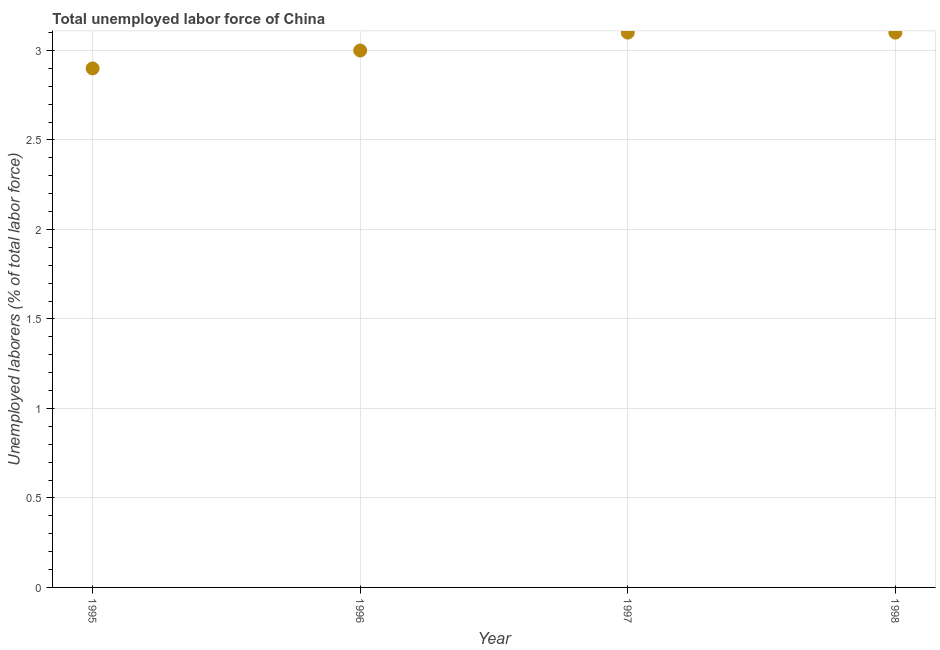What is the total unemployed labour force in 1997?
Make the answer very short. 3.1. Across all years, what is the maximum total unemployed labour force?
Give a very brief answer. 3.1. Across all years, what is the minimum total unemployed labour force?
Make the answer very short. 2.9. In which year was the total unemployed labour force maximum?
Offer a very short reply. 1997. What is the sum of the total unemployed labour force?
Your response must be concise. 12.1. What is the difference between the total unemployed labour force in 1996 and 1998?
Your answer should be compact. -0.1. What is the average total unemployed labour force per year?
Provide a succinct answer. 3.02. What is the median total unemployed labour force?
Ensure brevity in your answer.  3.05. In how many years, is the total unemployed labour force greater than 2.5 %?
Ensure brevity in your answer.  4. What is the ratio of the total unemployed labour force in 1996 to that in 1998?
Your answer should be compact. 0.97. Is the total unemployed labour force in 1995 less than that in 1997?
Make the answer very short. Yes. What is the difference between the highest and the lowest total unemployed labour force?
Make the answer very short. 0.2. In how many years, is the total unemployed labour force greater than the average total unemployed labour force taken over all years?
Ensure brevity in your answer.  2. Does the total unemployed labour force monotonically increase over the years?
Offer a terse response. No. How many years are there in the graph?
Your answer should be very brief. 4. What is the title of the graph?
Give a very brief answer. Total unemployed labor force of China. What is the label or title of the X-axis?
Provide a short and direct response. Year. What is the label or title of the Y-axis?
Offer a terse response. Unemployed laborers (% of total labor force). What is the Unemployed laborers (% of total labor force) in 1995?
Provide a succinct answer. 2.9. What is the Unemployed laborers (% of total labor force) in 1996?
Provide a succinct answer. 3. What is the Unemployed laborers (% of total labor force) in 1997?
Keep it short and to the point. 3.1. What is the Unemployed laborers (% of total labor force) in 1998?
Your answer should be compact. 3.1. What is the difference between the Unemployed laborers (% of total labor force) in 1995 and 1996?
Offer a very short reply. -0.1. What is the difference between the Unemployed laborers (% of total labor force) in 1997 and 1998?
Give a very brief answer. 0. What is the ratio of the Unemployed laborers (% of total labor force) in 1995 to that in 1996?
Make the answer very short. 0.97. What is the ratio of the Unemployed laborers (% of total labor force) in 1995 to that in 1997?
Give a very brief answer. 0.94. What is the ratio of the Unemployed laborers (% of total labor force) in 1995 to that in 1998?
Your answer should be very brief. 0.94. What is the ratio of the Unemployed laborers (% of total labor force) in 1996 to that in 1998?
Offer a very short reply. 0.97. 